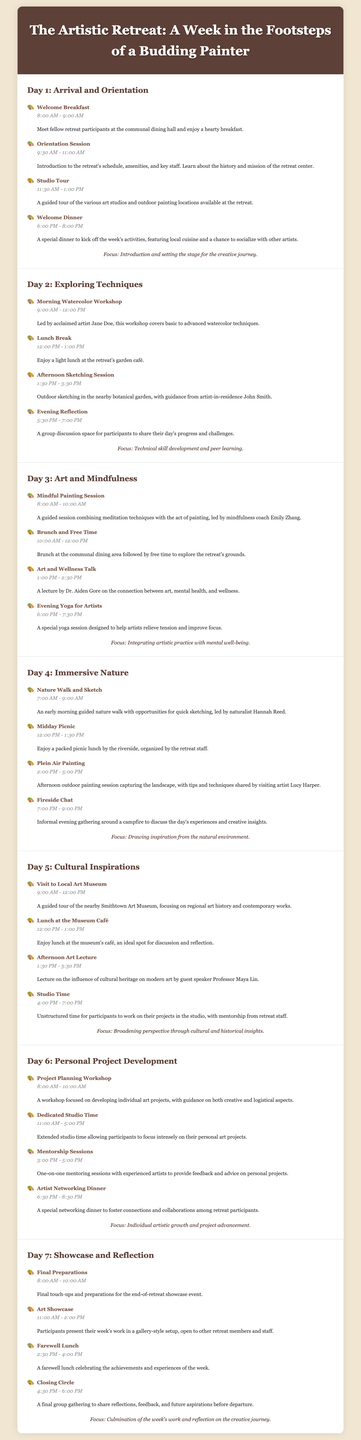What time does the welcome breakfast start? The welcome breakfast starts at 8:00 AM as listed in the Day 1 activities.
Answer: 8:00 AM Who leads the morning watercolor workshop? The morning watercolor workshop on Day 2 is led by acclaimed artist Jane Doe.
Answer: Jane Doe What is the focus of Day 3? The focus of Day 3 is integrating artistic practice with mental well-being.
Answer: Integrating artistic practice with mental well-being How long is the dedicated studio time on Day 6? The dedicated studio time on Day 6 lasts from 11:00 AM to 5:00 PM, which is 6 hours.
Answer: 6 hours What type of session follows the nature walk on Day 4? The session that follows the nature walk on Day 4 is a midday picnic.
Answer: Midday Picnic What is included in the final day's schedule? The final day's schedule includes final preparations, art showcase, farewell lunch, and closing circle.
Answer: Final preparations, art showcase, farewell lunch, and closing circle 